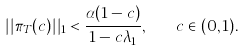<formula> <loc_0><loc_0><loc_500><loc_500>| | \pi _ { T } ( c ) | | _ { 1 } < \frac { \alpha ( 1 - c ) } { 1 - c \lambda _ { 1 } } , \quad c \in ( 0 , 1 ) .</formula> 